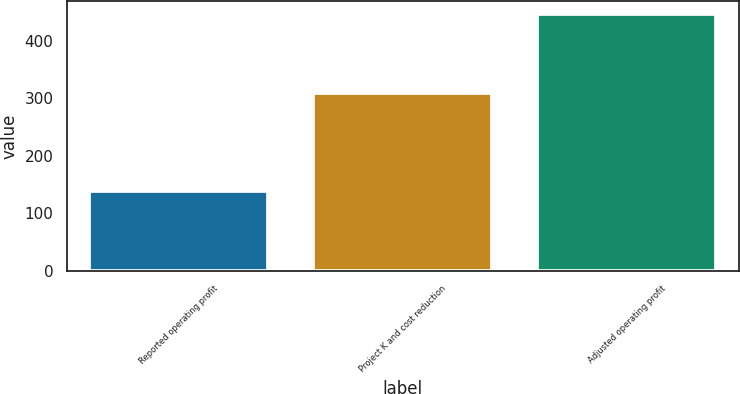Convert chart to OTSL. <chart><loc_0><loc_0><loc_500><loc_500><bar_chart><fcel>Reported operating profit<fcel>Project K and cost reduction<fcel>Adjusted operating profit<nl><fcel>138<fcel>309<fcel>447<nl></chart> 